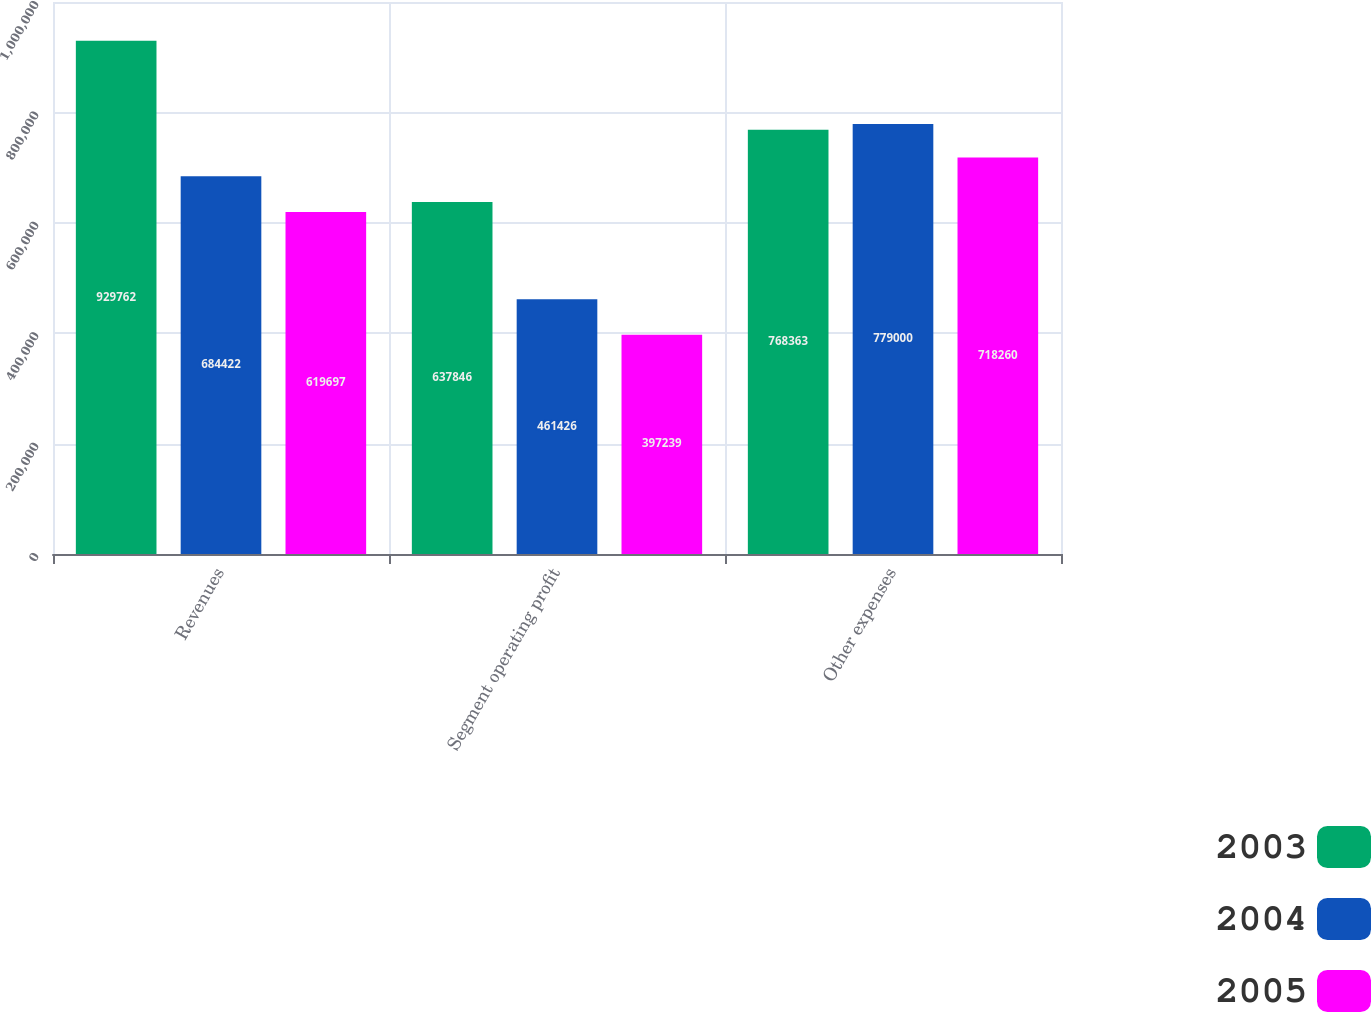Convert chart to OTSL. <chart><loc_0><loc_0><loc_500><loc_500><stacked_bar_chart><ecel><fcel>Revenues<fcel>Segment operating profit<fcel>Other expenses<nl><fcel>2003<fcel>929762<fcel>637846<fcel>768363<nl><fcel>2004<fcel>684422<fcel>461426<fcel>779000<nl><fcel>2005<fcel>619697<fcel>397239<fcel>718260<nl></chart> 